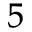<formula> <loc_0><loc_0><loc_500><loc_500>^ { 5 }</formula> 